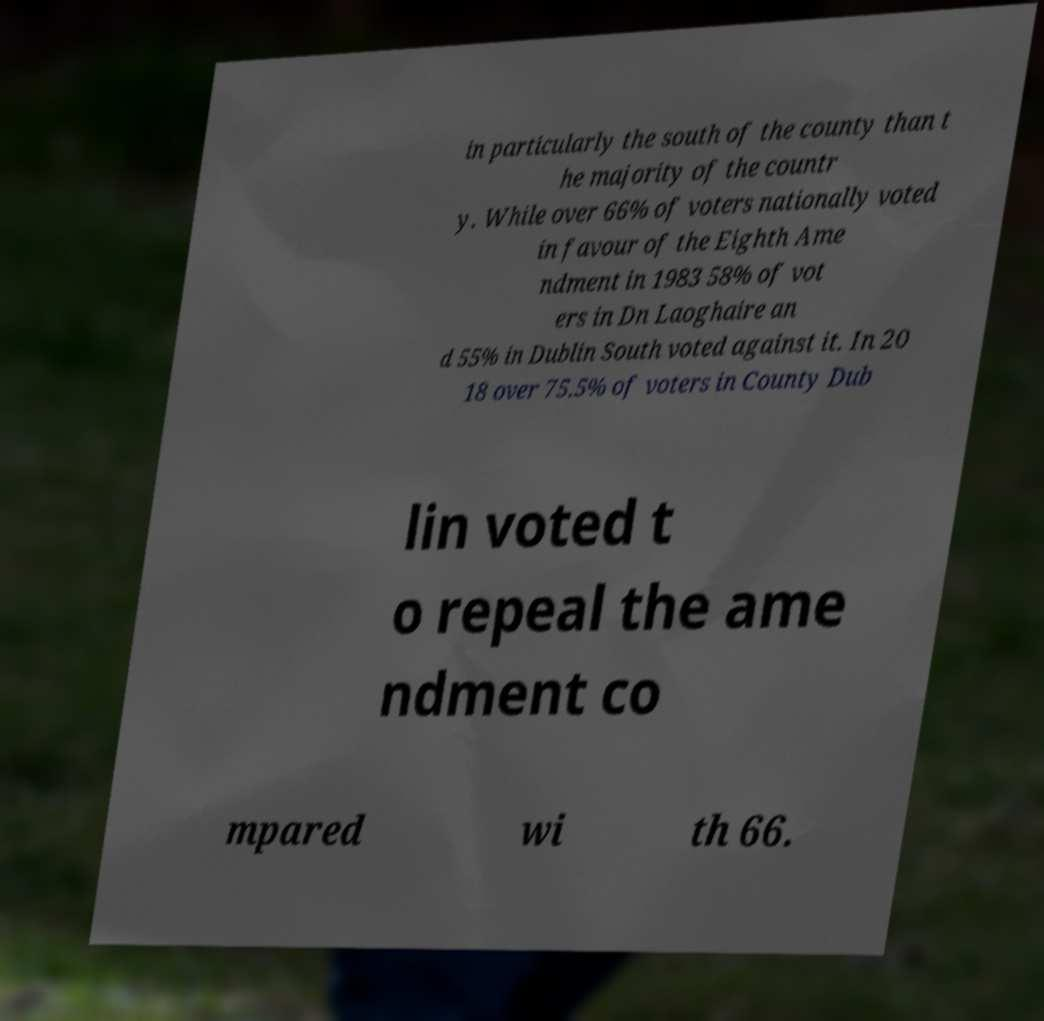For documentation purposes, I need the text within this image transcribed. Could you provide that? in particularly the south of the county than t he majority of the countr y. While over 66% of voters nationally voted in favour of the Eighth Ame ndment in 1983 58% of vot ers in Dn Laoghaire an d 55% in Dublin South voted against it. In 20 18 over 75.5% of voters in County Dub lin voted t o repeal the ame ndment co mpared wi th 66. 